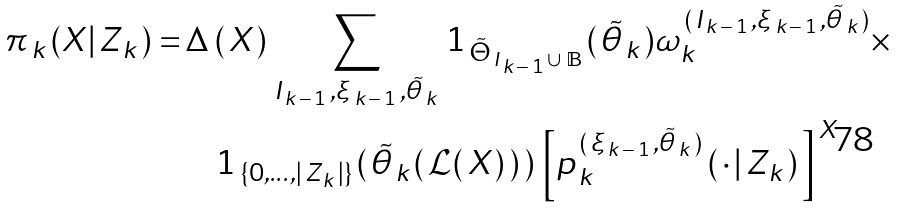<formula> <loc_0><loc_0><loc_500><loc_500>\, \pi _ { _ { \, } k \, } ( X _ { \, } | _ { \, } Z _ { _ { \, } k \, } ) = & \, \Delta _ { \, } ( _ { \, } X _ { \, } ) \, \sum _ { I _ { _ { \, } k _ { \, } - _ { \, } 1 } \, , \xi _ { _ { \, } k _ { \, } - _ { \, } 1 } \, , \tilde { \theta } _ { _ { \, } k } } \, 1 _ { _ { \, } { \tilde { \Theta } } _ { _ { \, } I _ { _ { \, } k _ { \, } - _ { \, } 1 \, } \cup _ { _ { \, } } \mathbb { B } \, } } ( _ { \, } \tilde { \theta } _ { _ { \, } k \, } ) \omega _ { k } ^ { _ { \, } ( _ { \, } I _ { _ { \, } k _ { \, } - _ { \, } 1 \, } , \xi _ { _ { \, } k _ { \, } - _ { \, } 1 \, } , \tilde { \theta } _ { _ { \, } k \, } ) } \times \\ & \quad 1 _ { _ { \, } \{ 0 , \dots , | _ { \, } Z _ { \, k \, } | \} \, } ( _ { \, } \tilde { \theta } _ { _ { \, } k _ { \, } } ( _ { \, } \mathcal { L } ( _ { \, } X _ { \, } ) { \, } ) \, ) \, \left [ p _ { _ { \, } k _ { _ { \, } } } ^ { _ { \, } ( _ { \, } \xi _ { _ { \, } k _ { \, } - _ { \, } 1 \, } , \tilde { \theta } _ { _ { \, } k \, } ) } \, ( _ { \, } \cdot _ { _ { \, } } | _ { _ { \, } } Z _ { _ { \, } k \, } ) _ { \, } \right ] ^ { \, X }</formula> 